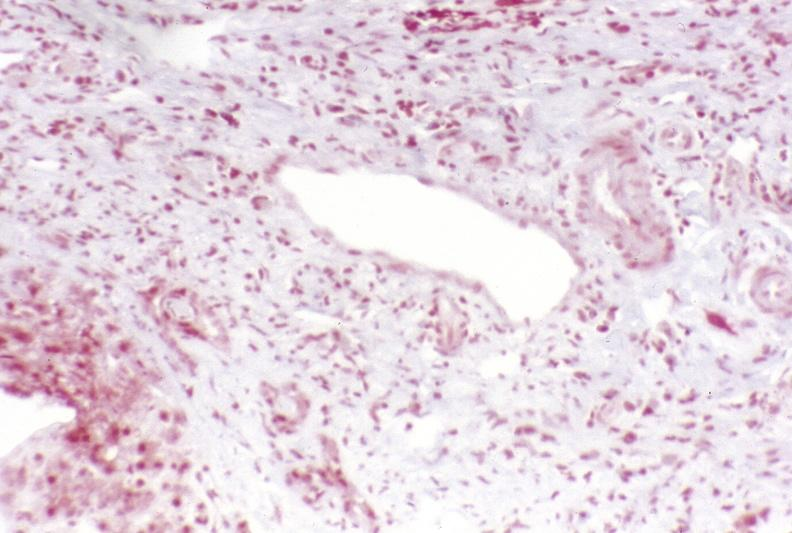s carcinomatosis present?
Answer the question using a single word or phrase. No 